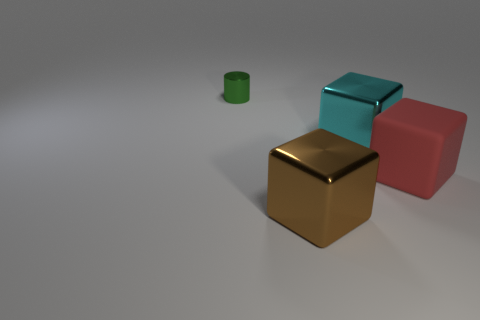Subtract all shiny cubes. How many cubes are left? 1 Add 1 large brown things. How many objects exist? 5 Subtract all cyan cubes. How many cubes are left? 2 Subtract all cylinders. How many objects are left? 3 Subtract all red blocks. Subtract all red balls. How many blocks are left? 2 Subtract all small things. Subtract all cyan blocks. How many objects are left? 2 Add 2 brown objects. How many brown objects are left? 3 Add 2 green shiny cylinders. How many green shiny cylinders exist? 3 Subtract 1 green cylinders. How many objects are left? 3 